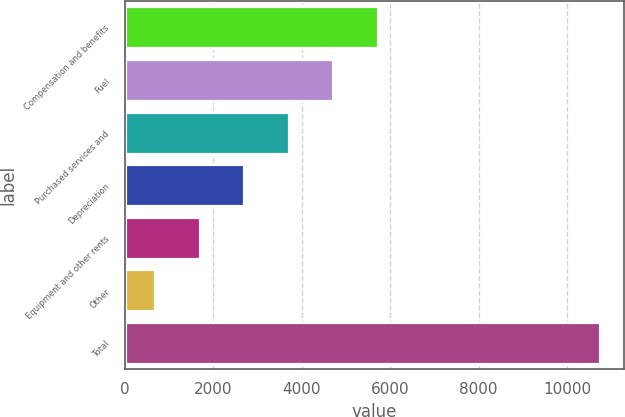Convert chart. <chart><loc_0><loc_0><loc_500><loc_500><bar_chart><fcel>Compensation and benefits<fcel>Fuel<fcel>Purchased services and<fcel>Depreciation<fcel>Equipment and other rents<fcel>Other<fcel>Total<nl><fcel>5719<fcel>4712.6<fcel>3706.2<fcel>2699.8<fcel>1693.4<fcel>687<fcel>10751<nl></chart> 